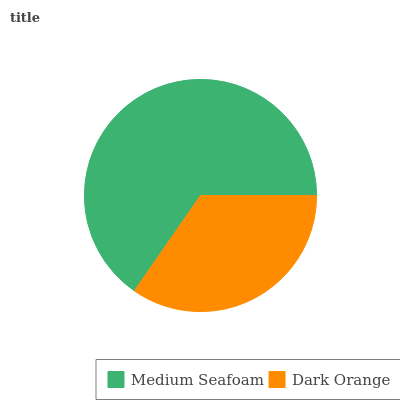Is Dark Orange the minimum?
Answer yes or no. Yes. Is Medium Seafoam the maximum?
Answer yes or no. Yes. Is Dark Orange the maximum?
Answer yes or no. No. Is Medium Seafoam greater than Dark Orange?
Answer yes or no. Yes. Is Dark Orange less than Medium Seafoam?
Answer yes or no. Yes. Is Dark Orange greater than Medium Seafoam?
Answer yes or no. No. Is Medium Seafoam less than Dark Orange?
Answer yes or no. No. Is Medium Seafoam the high median?
Answer yes or no. Yes. Is Dark Orange the low median?
Answer yes or no. Yes. Is Dark Orange the high median?
Answer yes or no. No. Is Medium Seafoam the low median?
Answer yes or no. No. 